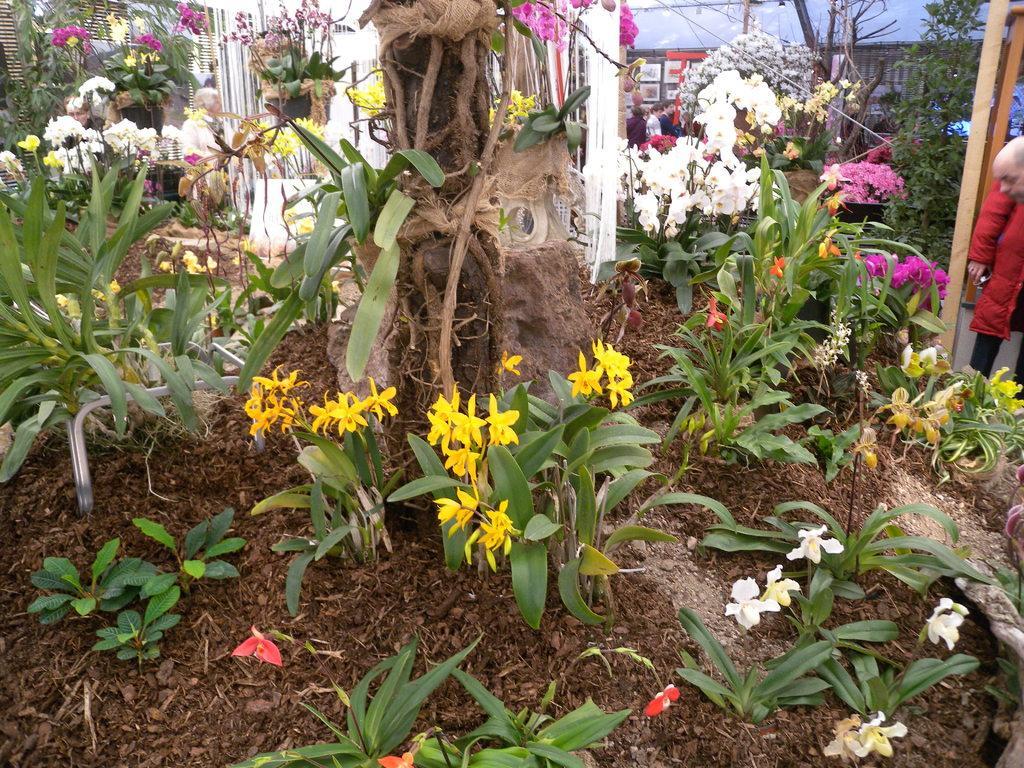Describe this image in one or two sentences. In the picture it looks like a nursery, there are plenty of beautiful plants and there are few people in between those plants. 